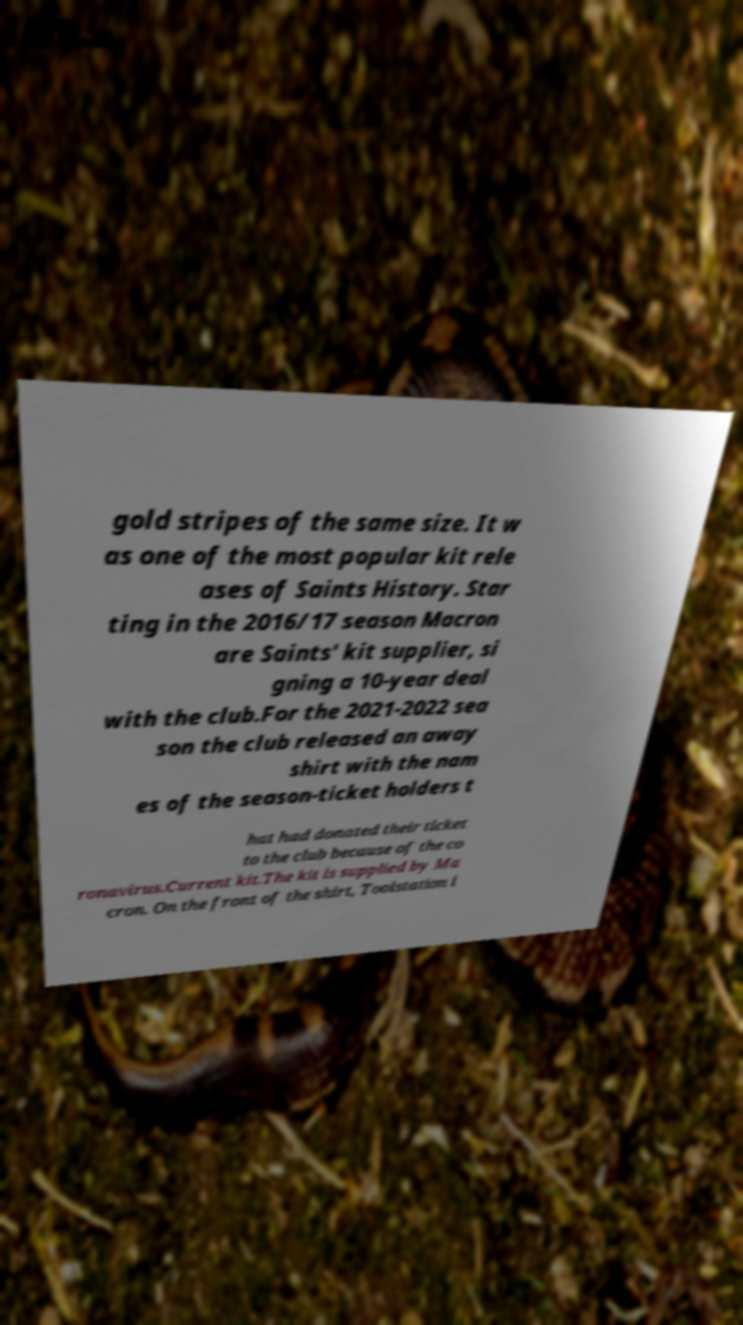Could you extract and type out the text from this image? gold stripes of the same size. It w as one of the most popular kit rele ases of Saints History. Star ting in the 2016/17 season Macron are Saints' kit supplier, si gning a 10-year deal with the club.For the 2021-2022 sea son the club released an away shirt with the nam es of the season-ticket holders t hat had donated their ticket to the club because of the co ronavirus.Current kit.The kit is supplied by Ma cron. On the front of the shirt, Toolstation i 